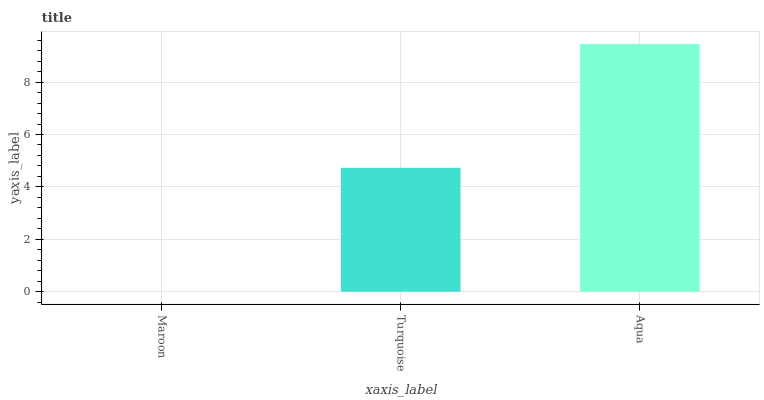Is Maroon the minimum?
Answer yes or no. Yes. Is Aqua the maximum?
Answer yes or no. Yes. Is Turquoise the minimum?
Answer yes or no. No. Is Turquoise the maximum?
Answer yes or no. No. Is Turquoise greater than Maroon?
Answer yes or no. Yes. Is Maroon less than Turquoise?
Answer yes or no. Yes. Is Maroon greater than Turquoise?
Answer yes or no. No. Is Turquoise less than Maroon?
Answer yes or no. No. Is Turquoise the high median?
Answer yes or no. Yes. Is Turquoise the low median?
Answer yes or no. Yes. Is Maroon the high median?
Answer yes or no. No. Is Aqua the low median?
Answer yes or no. No. 